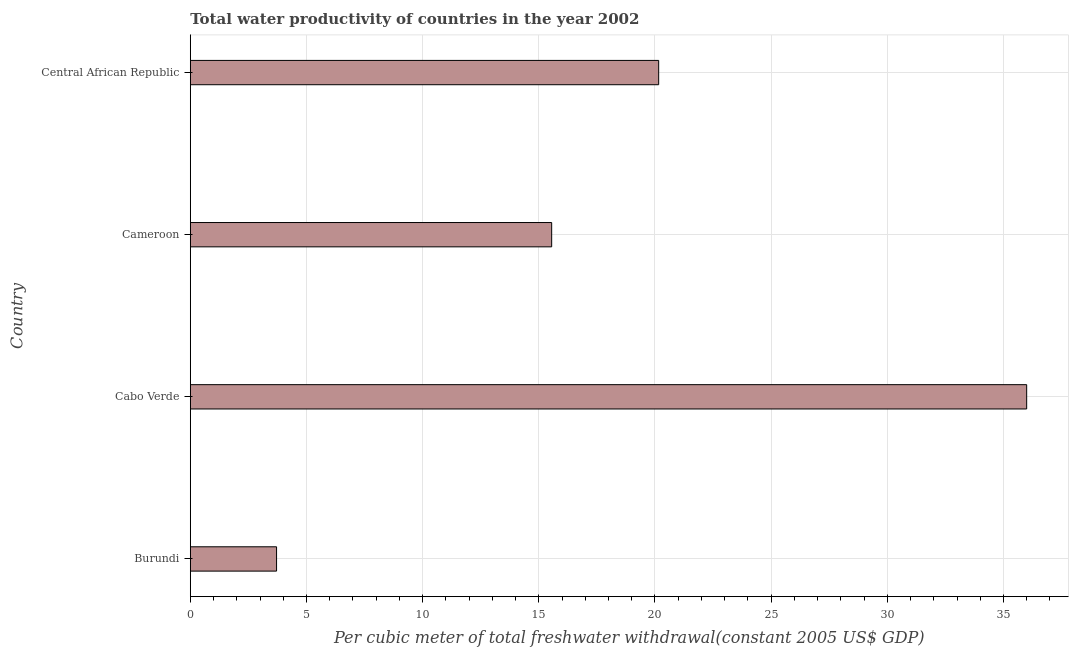Does the graph contain grids?
Your answer should be very brief. Yes. What is the title of the graph?
Keep it short and to the point. Total water productivity of countries in the year 2002. What is the label or title of the X-axis?
Ensure brevity in your answer.  Per cubic meter of total freshwater withdrawal(constant 2005 US$ GDP). What is the label or title of the Y-axis?
Your answer should be very brief. Country. What is the total water productivity in Cabo Verde?
Make the answer very short. 36. Across all countries, what is the maximum total water productivity?
Ensure brevity in your answer.  36. Across all countries, what is the minimum total water productivity?
Make the answer very short. 3.71. In which country was the total water productivity maximum?
Provide a succinct answer. Cabo Verde. In which country was the total water productivity minimum?
Give a very brief answer. Burundi. What is the sum of the total water productivity?
Give a very brief answer. 75.42. What is the difference between the total water productivity in Cabo Verde and Central African Republic?
Your response must be concise. 15.84. What is the average total water productivity per country?
Offer a very short reply. 18.86. What is the median total water productivity?
Provide a short and direct response. 17.86. What is the ratio of the total water productivity in Burundi to that in Cabo Verde?
Your response must be concise. 0.1. What is the difference between the highest and the second highest total water productivity?
Your answer should be compact. 15.84. What is the difference between the highest and the lowest total water productivity?
Keep it short and to the point. 32.28. How many bars are there?
Provide a short and direct response. 4. Are all the bars in the graph horizontal?
Provide a succinct answer. Yes. How many countries are there in the graph?
Keep it short and to the point. 4. What is the difference between two consecutive major ticks on the X-axis?
Your answer should be compact. 5. Are the values on the major ticks of X-axis written in scientific E-notation?
Keep it short and to the point. No. What is the Per cubic meter of total freshwater withdrawal(constant 2005 US$ GDP) of Burundi?
Your response must be concise. 3.71. What is the Per cubic meter of total freshwater withdrawal(constant 2005 US$ GDP) of Cabo Verde?
Ensure brevity in your answer.  36. What is the Per cubic meter of total freshwater withdrawal(constant 2005 US$ GDP) in Cameroon?
Your response must be concise. 15.55. What is the Per cubic meter of total freshwater withdrawal(constant 2005 US$ GDP) of Central African Republic?
Offer a very short reply. 20.16. What is the difference between the Per cubic meter of total freshwater withdrawal(constant 2005 US$ GDP) in Burundi and Cabo Verde?
Your answer should be compact. -32.28. What is the difference between the Per cubic meter of total freshwater withdrawal(constant 2005 US$ GDP) in Burundi and Cameroon?
Keep it short and to the point. -11.84. What is the difference between the Per cubic meter of total freshwater withdrawal(constant 2005 US$ GDP) in Burundi and Central African Republic?
Your response must be concise. -16.45. What is the difference between the Per cubic meter of total freshwater withdrawal(constant 2005 US$ GDP) in Cabo Verde and Cameroon?
Make the answer very short. 20.44. What is the difference between the Per cubic meter of total freshwater withdrawal(constant 2005 US$ GDP) in Cabo Verde and Central African Republic?
Your answer should be compact. 15.84. What is the difference between the Per cubic meter of total freshwater withdrawal(constant 2005 US$ GDP) in Cameroon and Central African Republic?
Give a very brief answer. -4.61. What is the ratio of the Per cubic meter of total freshwater withdrawal(constant 2005 US$ GDP) in Burundi to that in Cabo Verde?
Your answer should be very brief. 0.1. What is the ratio of the Per cubic meter of total freshwater withdrawal(constant 2005 US$ GDP) in Burundi to that in Cameroon?
Offer a very short reply. 0.24. What is the ratio of the Per cubic meter of total freshwater withdrawal(constant 2005 US$ GDP) in Burundi to that in Central African Republic?
Your answer should be very brief. 0.18. What is the ratio of the Per cubic meter of total freshwater withdrawal(constant 2005 US$ GDP) in Cabo Verde to that in Cameroon?
Your answer should be compact. 2.31. What is the ratio of the Per cubic meter of total freshwater withdrawal(constant 2005 US$ GDP) in Cabo Verde to that in Central African Republic?
Provide a succinct answer. 1.79. What is the ratio of the Per cubic meter of total freshwater withdrawal(constant 2005 US$ GDP) in Cameroon to that in Central African Republic?
Provide a short and direct response. 0.77. 